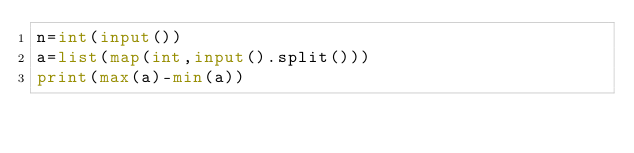<code> <loc_0><loc_0><loc_500><loc_500><_Python_>n=int(input())
a=list(map(int,input().split()))
print(max(a)-min(a))</code> 